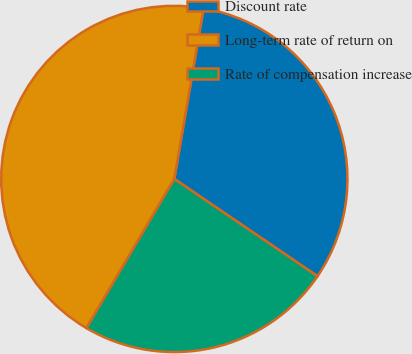<chart> <loc_0><loc_0><loc_500><loc_500><pie_chart><fcel>Discount rate<fcel>Long-term rate of return on<fcel>Rate of compensation increase<nl><fcel>31.79%<fcel>44.23%<fcel>23.97%<nl></chart> 